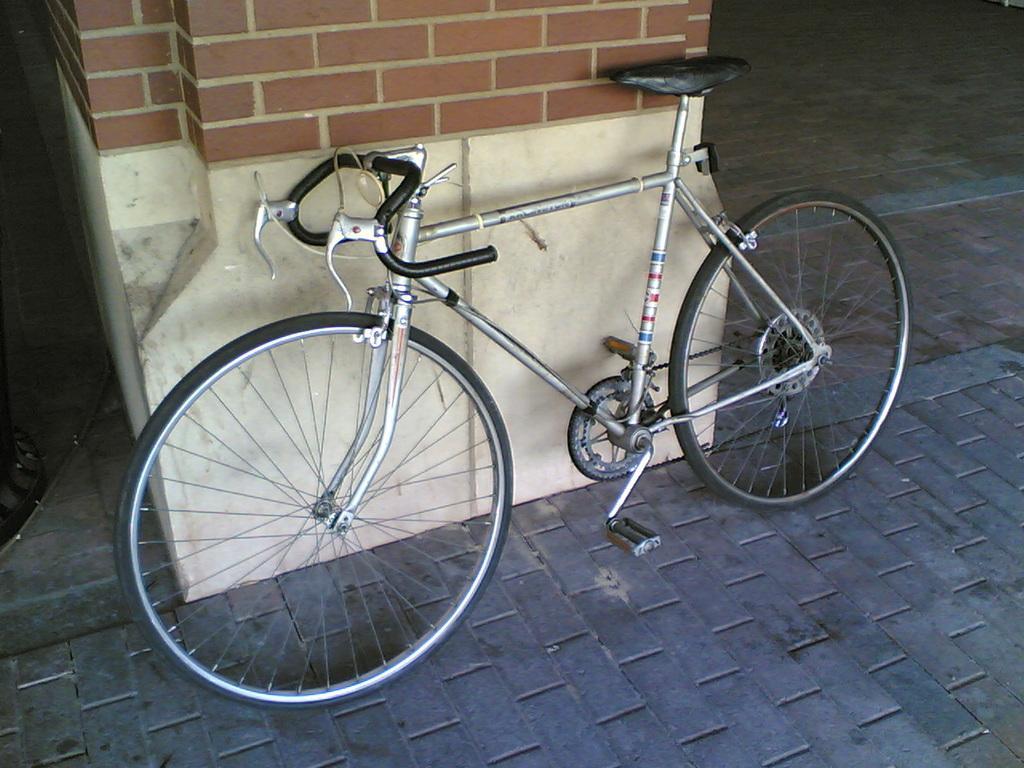How would you summarize this image in a sentence or two? In this image we can see a bicycle placed on the ground. In the background,we can see a wall. 